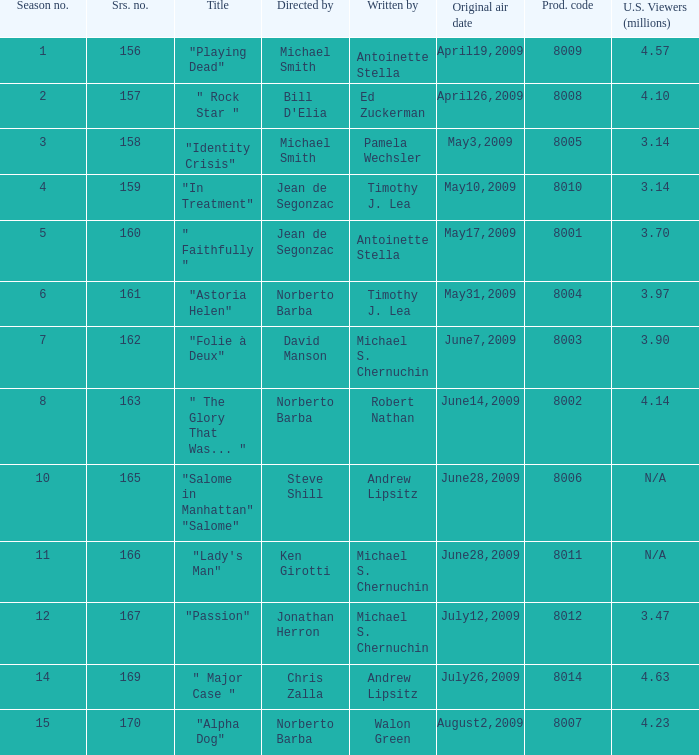Which is the  maximun serie episode number when the millions of north american spectators is 3.14? 159.0. 